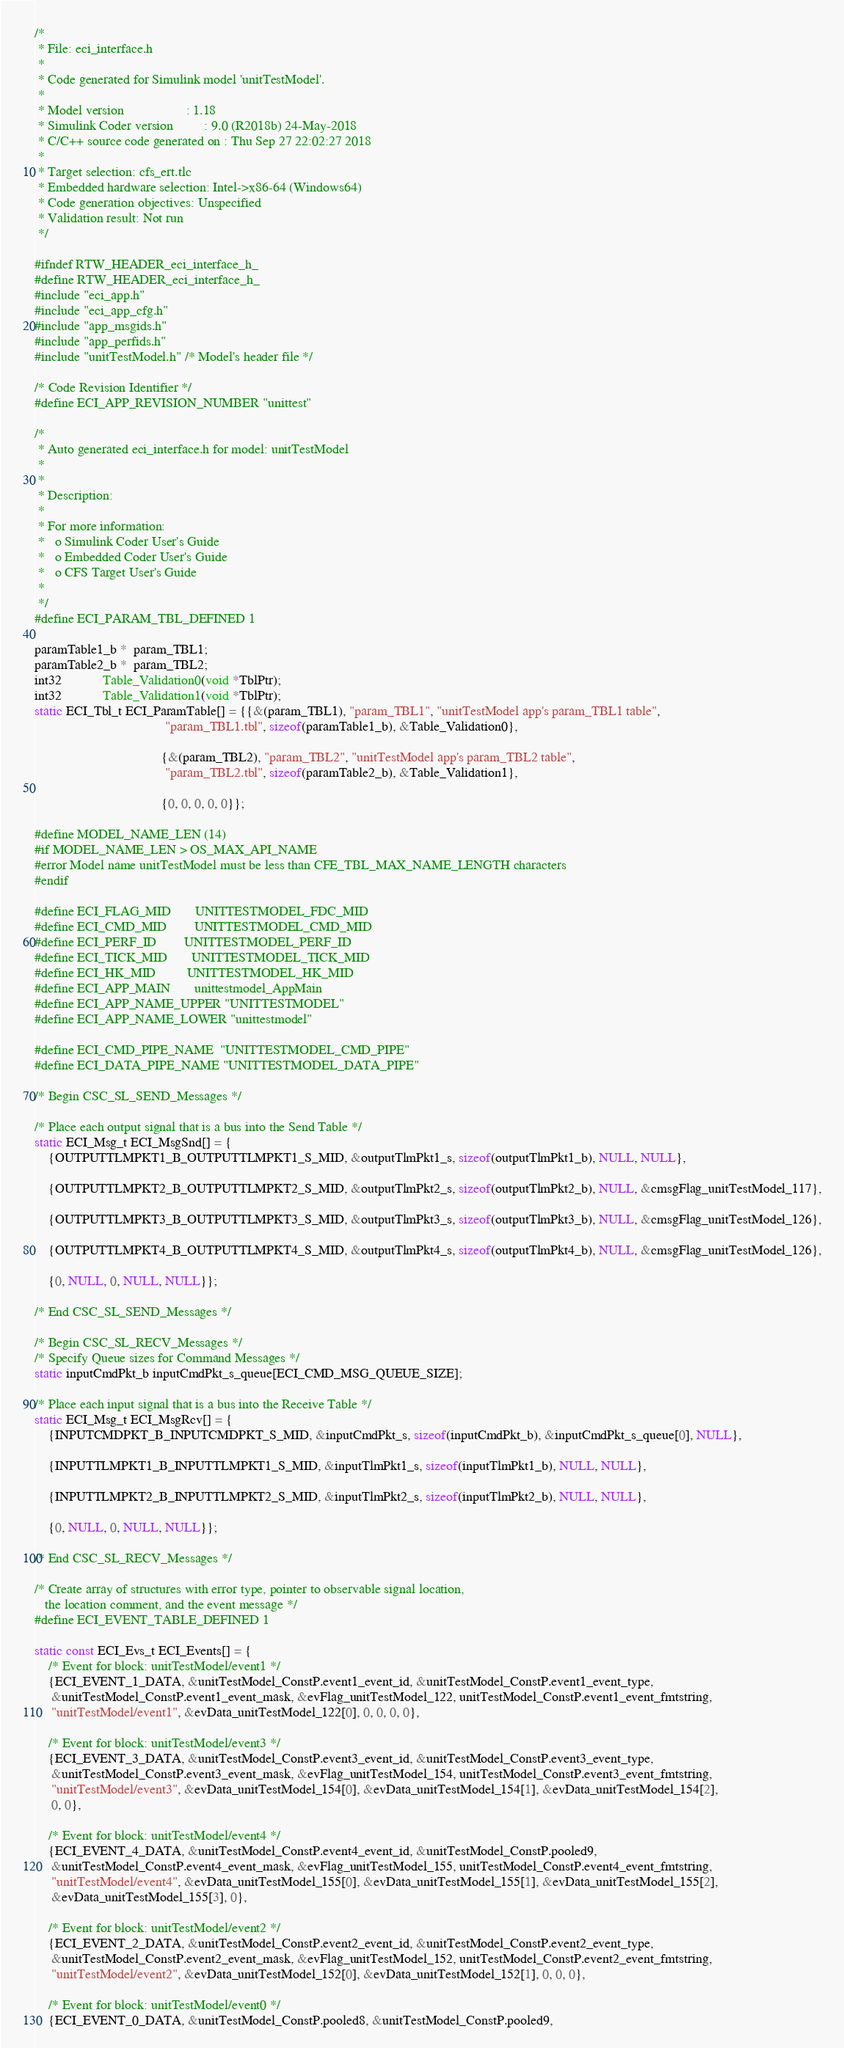Convert code to text. <code><loc_0><loc_0><loc_500><loc_500><_C_>/*
 * File: eci_interface.h
 *
 * Code generated for Simulink model 'unitTestModel'.
 *
 * Model version                  : 1.18
 * Simulink Coder version         : 9.0 (R2018b) 24-May-2018
 * C/C++ source code generated on : Thu Sep 27 22:02:27 2018
 *
 * Target selection: cfs_ert.tlc
 * Embedded hardware selection: Intel->x86-64 (Windows64)
 * Code generation objectives: Unspecified
 * Validation result: Not run
 */

#ifndef RTW_HEADER_eci_interface_h_
#define RTW_HEADER_eci_interface_h_
#include "eci_app.h"
#include "eci_app_cfg.h"
#include "app_msgids.h"
#include "app_perfids.h"
#include "unitTestModel.h" /* Model's header file */

/* Code Revision Identifier */
#define ECI_APP_REVISION_NUMBER "unittest"

/*
 * Auto generated eci_interface.h for model: unitTestModel
 *
 *
 * Description:
 *
 * For more information:
 *   o Simulink Coder User's Guide
 *   o Embedded Coder User's Guide
 *   o CFS Target User's Guide
 *
 */
#define ECI_PARAM_TBL_DEFINED 1

paramTable1_b *  param_TBL1;
paramTable2_b *  param_TBL2;
int32            Table_Validation0(void *TblPtr);
int32            Table_Validation1(void *TblPtr);
static ECI_Tbl_t ECI_ParamTable[] = {{&(param_TBL1), "param_TBL1", "unitTestModel app's param_TBL1 table",
                                      "param_TBL1.tbl", sizeof(paramTable1_b), &Table_Validation0},

                                     {&(param_TBL2), "param_TBL2", "unitTestModel app's param_TBL2 table",
                                      "param_TBL2.tbl", sizeof(paramTable2_b), &Table_Validation1},

                                     {0, 0, 0, 0, 0}};

#define MODEL_NAME_LEN (14)
#if MODEL_NAME_LEN > OS_MAX_API_NAME
#error Model name unitTestModel must be less than CFE_TBL_MAX_NAME_LENGTH characters
#endif

#define ECI_FLAG_MID       UNITTESTMODEL_FDC_MID
#define ECI_CMD_MID        UNITTESTMODEL_CMD_MID
#define ECI_PERF_ID        UNITTESTMODEL_PERF_ID
#define ECI_TICK_MID       UNITTESTMODEL_TICK_MID
#define ECI_HK_MID         UNITTESTMODEL_HK_MID
#define ECI_APP_MAIN       unittestmodel_AppMain
#define ECI_APP_NAME_UPPER "UNITTESTMODEL"
#define ECI_APP_NAME_LOWER "unittestmodel"

#define ECI_CMD_PIPE_NAME  "UNITTESTMODEL_CMD_PIPE"
#define ECI_DATA_PIPE_NAME "UNITTESTMODEL_DATA_PIPE"

/* Begin CSC_SL_SEND_Messages */

/* Place each output signal that is a bus into the Send Table */
static ECI_Msg_t ECI_MsgSnd[] = {
    {OUTPUTTLMPKT1_B_OUTPUTTLMPKT1_S_MID, &outputTlmPkt1_s, sizeof(outputTlmPkt1_b), NULL, NULL},

    {OUTPUTTLMPKT2_B_OUTPUTTLMPKT2_S_MID, &outputTlmPkt2_s, sizeof(outputTlmPkt2_b), NULL, &cmsgFlag_unitTestModel_117},

    {OUTPUTTLMPKT3_B_OUTPUTTLMPKT3_S_MID, &outputTlmPkt3_s, sizeof(outputTlmPkt3_b), NULL, &cmsgFlag_unitTestModel_126},

    {OUTPUTTLMPKT4_B_OUTPUTTLMPKT4_S_MID, &outputTlmPkt4_s, sizeof(outputTlmPkt4_b), NULL, &cmsgFlag_unitTestModel_126},

    {0, NULL, 0, NULL, NULL}};

/* End CSC_SL_SEND_Messages */

/* Begin CSC_SL_RECV_Messages */
/* Specify Queue sizes for Command Messages */
static inputCmdPkt_b inputCmdPkt_s_queue[ECI_CMD_MSG_QUEUE_SIZE];

/* Place each input signal that is a bus into the Receive Table */
static ECI_Msg_t ECI_MsgRcv[] = {
    {INPUTCMDPKT_B_INPUTCMDPKT_S_MID, &inputCmdPkt_s, sizeof(inputCmdPkt_b), &inputCmdPkt_s_queue[0], NULL},

    {INPUTTLMPKT1_B_INPUTTLMPKT1_S_MID, &inputTlmPkt1_s, sizeof(inputTlmPkt1_b), NULL, NULL},

    {INPUTTLMPKT2_B_INPUTTLMPKT2_S_MID, &inputTlmPkt2_s, sizeof(inputTlmPkt2_b), NULL, NULL},

    {0, NULL, 0, NULL, NULL}};

/* End CSC_SL_RECV_Messages */

/* Create array of structures with error type, pointer to observable signal location,
   the location comment, and the event message */
#define ECI_EVENT_TABLE_DEFINED 1

static const ECI_Evs_t ECI_Events[] = {
    /* Event for block: unitTestModel/event1 */
    {ECI_EVENT_1_DATA, &unitTestModel_ConstP.event1_event_id, &unitTestModel_ConstP.event1_event_type,
     &unitTestModel_ConstP.event1_event_mask, &evFlag_unitTestModel_122, unitTestModel_ConstP.event1_event_fmtstring,
     "unitTestModel/event1", &evData_unitTestModel_122[0], 0, 0, 0, 0},

    /* Event for block: unitTestModel/event3 */
    {ECI_EVENT_3_DATA, &unitTestModel_ConstP.event3_event_id, &unitTestModel_ConstP.event3_event_type,
     &unitTestModel_ConstP.event3_event_mask, &evFlag_unitTestModel_154, unitTestModel_ConstP.event3_event_fmtstring,
     "unitTestModel/event3", &evData_unitTestModel_154[0], &evData_unitTestModel_154[1], &evData_unitTestModel_154[2],
     0, 0},

    /* Event for block: unitTestModel/event4 */
    {ECI_EVENT_4_DATA, &unitTestModel_ConstP.event4_event_id, &unitTestModel_ConstP.pooled9,
     &unitTestModel_ConstP.event4_event_mask, &evFlag_unitTestModel_155, unitTestModel_ConstP.event4_event_fmtstring,
     "unitTestModel/event4", &evData_unitTestModel_155[0], &evData_unitTestModel_155[1], &evData_unitTestModel_155[2],
     &evData_unitTestModel_155[3], 0},

    /* Event for block: unitTestModel/event2 */
    {ECI_EVENT_2_DATA, &unitTestModel_ConstP.event2_event_id, &unitTestModel_ConstP.event2_event_type,
     &unitTestModel_ConstP.event2_event_mask, &evFlag_unitTestModel_152, unitTestModel_ConstP.event2_event_fmtstring,
     "unitTestModel/event2", &evData_unitTestModel_152[0], &evData_unitTestModel_152[1], 0, 0, 0},

    /* Event for block: unitTestModel/event0 */
    {ECI_EVENT_0_DATA, &unitTestModel_ConstP.pooled8, &unitTestModel_ConstP.pooled9,</code> 